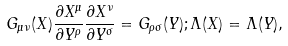Convert formula to latex. <formula><loc_0><loc_0><loc_500><loc_500>G _ { \mu \nu } ( X ) \frac { \partial X ^ { \mu } } { \partial Y ^ { \rho } } \frac { \partial X ^ { \nu } } { \partial Y ^ { \sigma } } = G _ { \rho \sigma } ( Y ) ; \Lambda ( X ) = \Lambda ( Y ) ,</formula> 